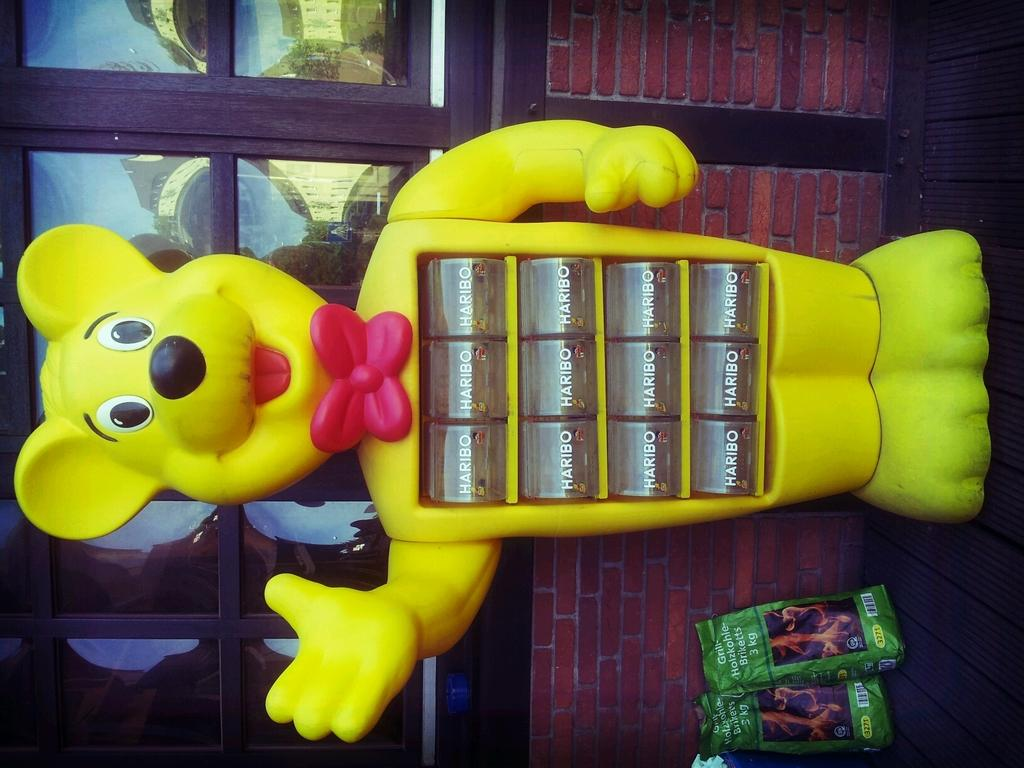What is on the floor in the image? There is a toy and packets on the floor. What can be seen in the background of the image? There is a wall and windows in the background of the image. What grade did the grandfather receive for his whistling performance in the image? There is no mention of a grandfather or whistling performance in the image. 